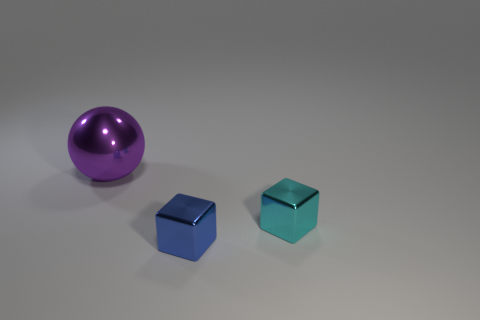Is the number of tiny cyan blocks that are in front of the cyan block the same as the number of shiny cubes that are in front of the large metallic ball? Upon reviewing the image, we see that there is only one cyan block and no tiny cyan blocks in front of it, making the number zero. Similarly, in front of the large metallic ball, there are no shiny cubes present at all. Therefore, since there are an equal number of tiny cyan blocks and shiny cubes in front of the respective objects, which is none, the most accurate answer is 'Yes, the number is the same because there are no tiny cyan blocks or shiny cubes directly in front of the mentioned objects.' 